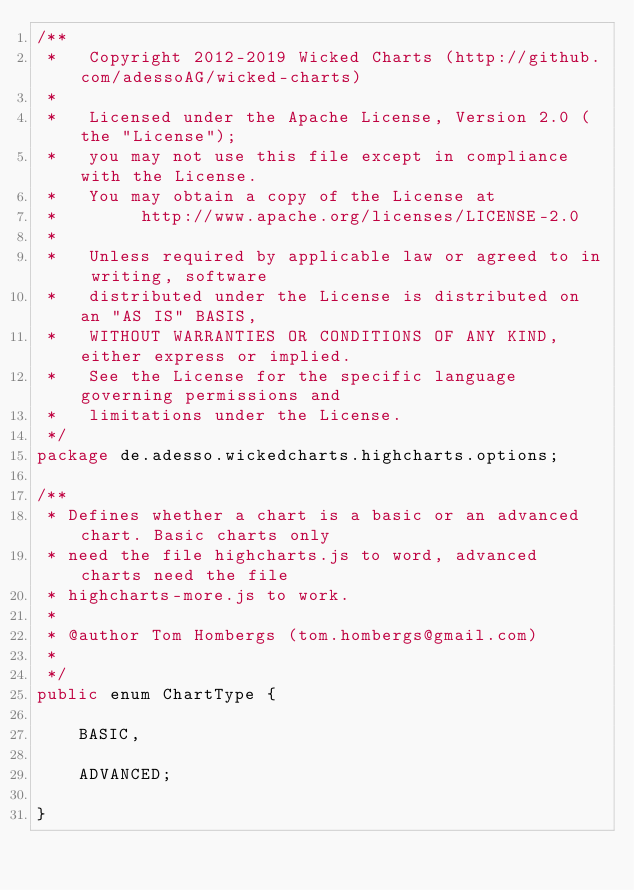<code> <loc_0><loc_0><loc_500><loc_500><_Java_>/**
 *   Copyright 2012-2019 Wicked Charts (http://github.com/adessoAG/wicked-charts)
 *
 *   Licensed under the Apache License, Version 2.0 (the "License");
 *   you may not use this file except in compliance with the License.
 *   You may obtain a copy of the License at
 *        http://www.apache.org/licenses/LICENSE-2.0
 *
 *   Unless required by applicable law or agreed to in writing, software
 *   distributed under the License is distributed on an "AS IS" BASIS,
 *   WITHOUT WARRANTIES OR CONDITIONS OF ANY KIND, either express or implied.
 *   See the License for the specific language governing permissions and
 *   limitations under the License.
 */
package de.adesso.wickedcharts.highcharts.options;

/**
 * Defines whether a chart is a basic or an advanced chart. Basic charts only
 * need the file highcharts.js to word, advanced charts need the file
 * highcharts-more.js to work.
 * 
 * @author Tom Hombergs (tom.hombergs@gmail.com)
 * 
 */
public enum ChartType {

	BASIC,

	ADVANCED;

}
</code> 